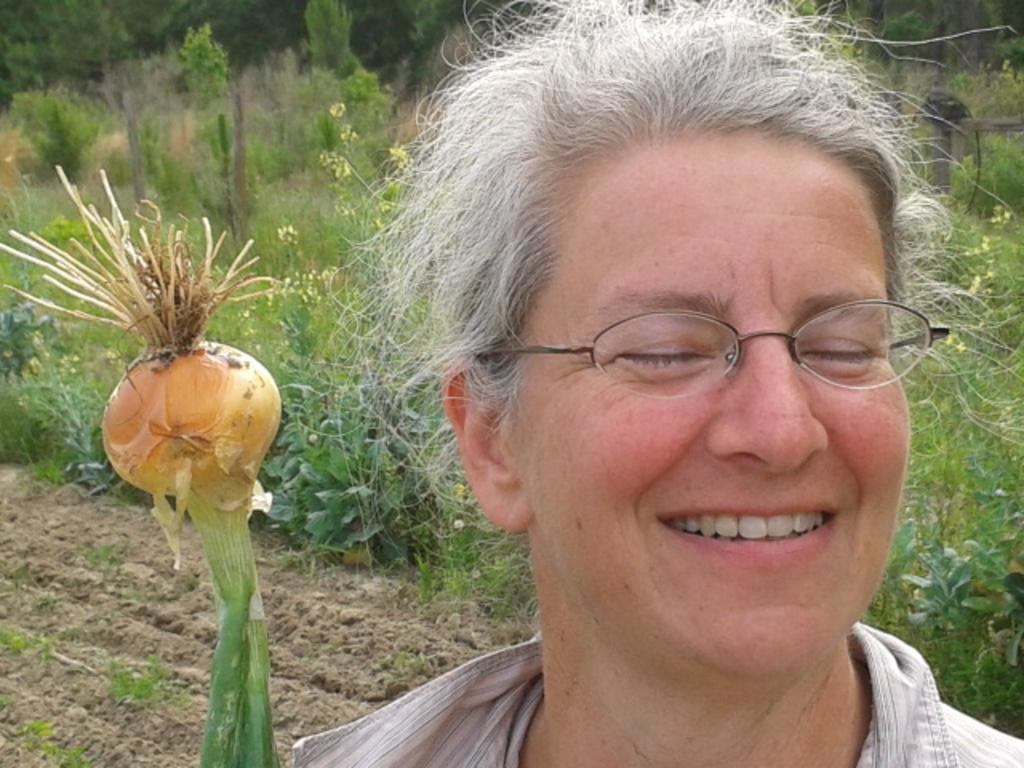Describe this image in one or two sentences. In this picture we can observe a woman smiling and she is wearing spectacles. She is holding a vegetable in her hand. In the background we can observe some plants. There are some trees. 